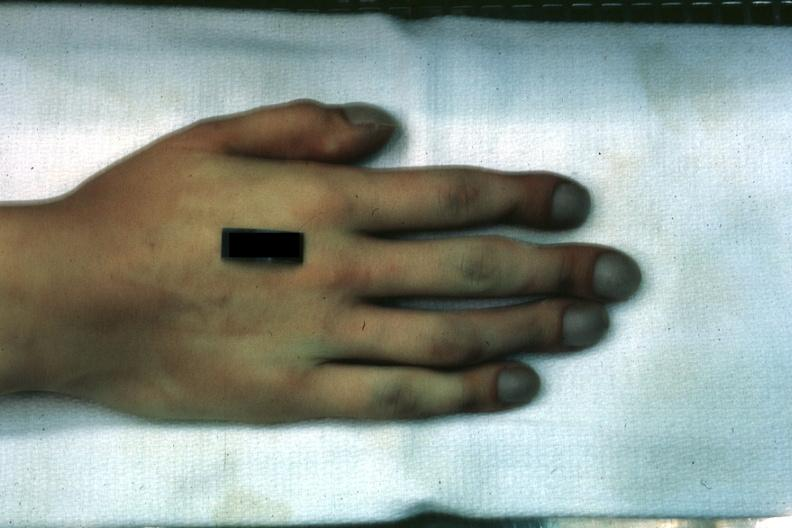re extremities present?
Answer the question using a single word or phrase. Yes 